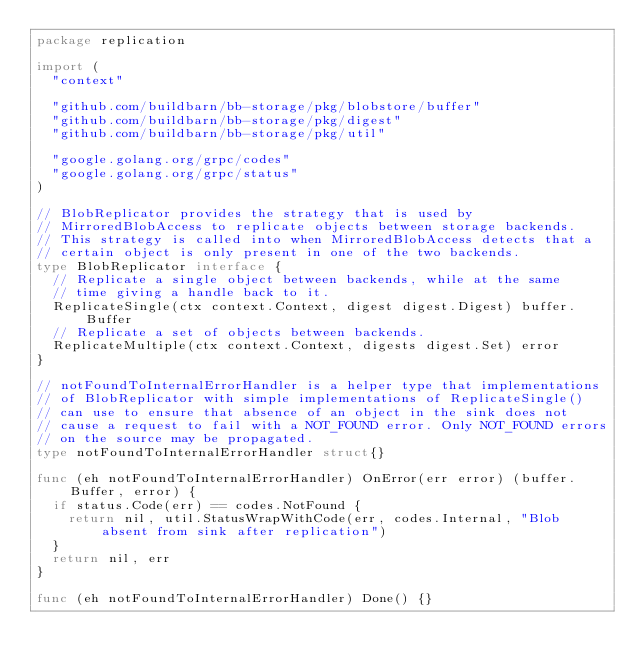<code> <loc_0><loc_0><loc_500><loc_500><_Go_>package replication

import (
	"context"

	"github.com/buildbarn/bb-storage/pkg/blobstore/buffer"
	"github.com/buildbarn/bb-storage/pkg/digest"
	"github.com/buildbarn/bb-storage/pkg/util"

	"google.golang.org/grpc/codes"
	"google.golang.org/grpc/status"
)

// BlobReplicator provides the strategy that is used by
// MirroredBlobAccess to replicate objects between storage backends.
// This strategy is called into when MirroredBlobAccess detects that a
// certain object is only present in one of the two backends.
type BlobReplicator interface {
	// Replicate a single object between backends, while at the same
	// time giving a handle back to it.
	ReplicateSingle(ctx context.Context, digest digest.Digest) buffer.Buffer
	// Replicate a set of objects between backends.
	ReplicateMultiple(ctx context.Context, digests digest.Set) error
}

// notFoundToInternalErrorHandler is a helper type that implementations
// of BlobReplicator with simple implementations of ReplicateSingle()
// can use to ensure that absence of an object in the sink does not
// cause a request to fail with a NOT_FOUND error. Only NOT_FOUND errors
// on the source may be propagated.
type notFoundToInternalErrorHandler struct{}

func (eh notFoundToInternalErrorHandler) OnError(err error) (buffer.Buffer, error) {
	if status.Code(err) == codes.NotFound {
		return nil, util.StatusWrapWithCode(err, codes.Internal, "Blob absent from sink after replication")
	}
	return nil, err
}

func (eh notFoundToInternalErrorHandler) Done() {}
</code> 